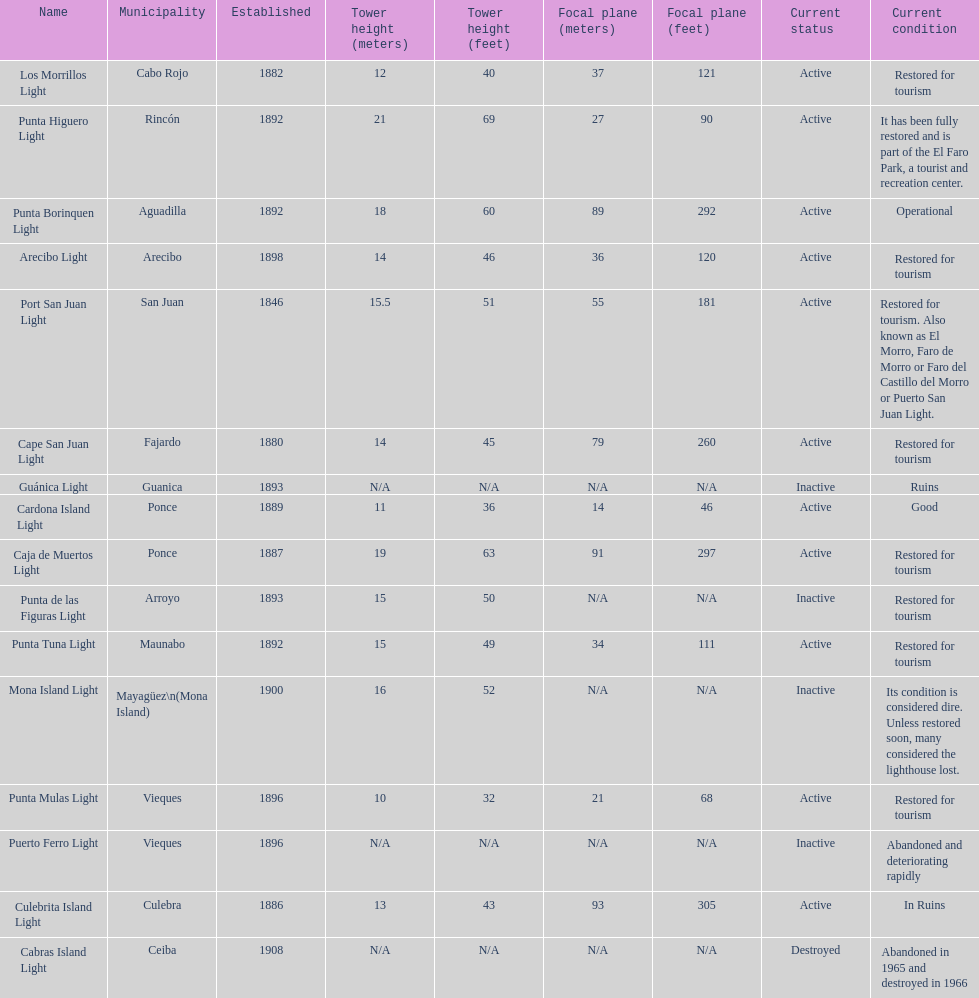What is the largest tower Punta Higuero Light. 